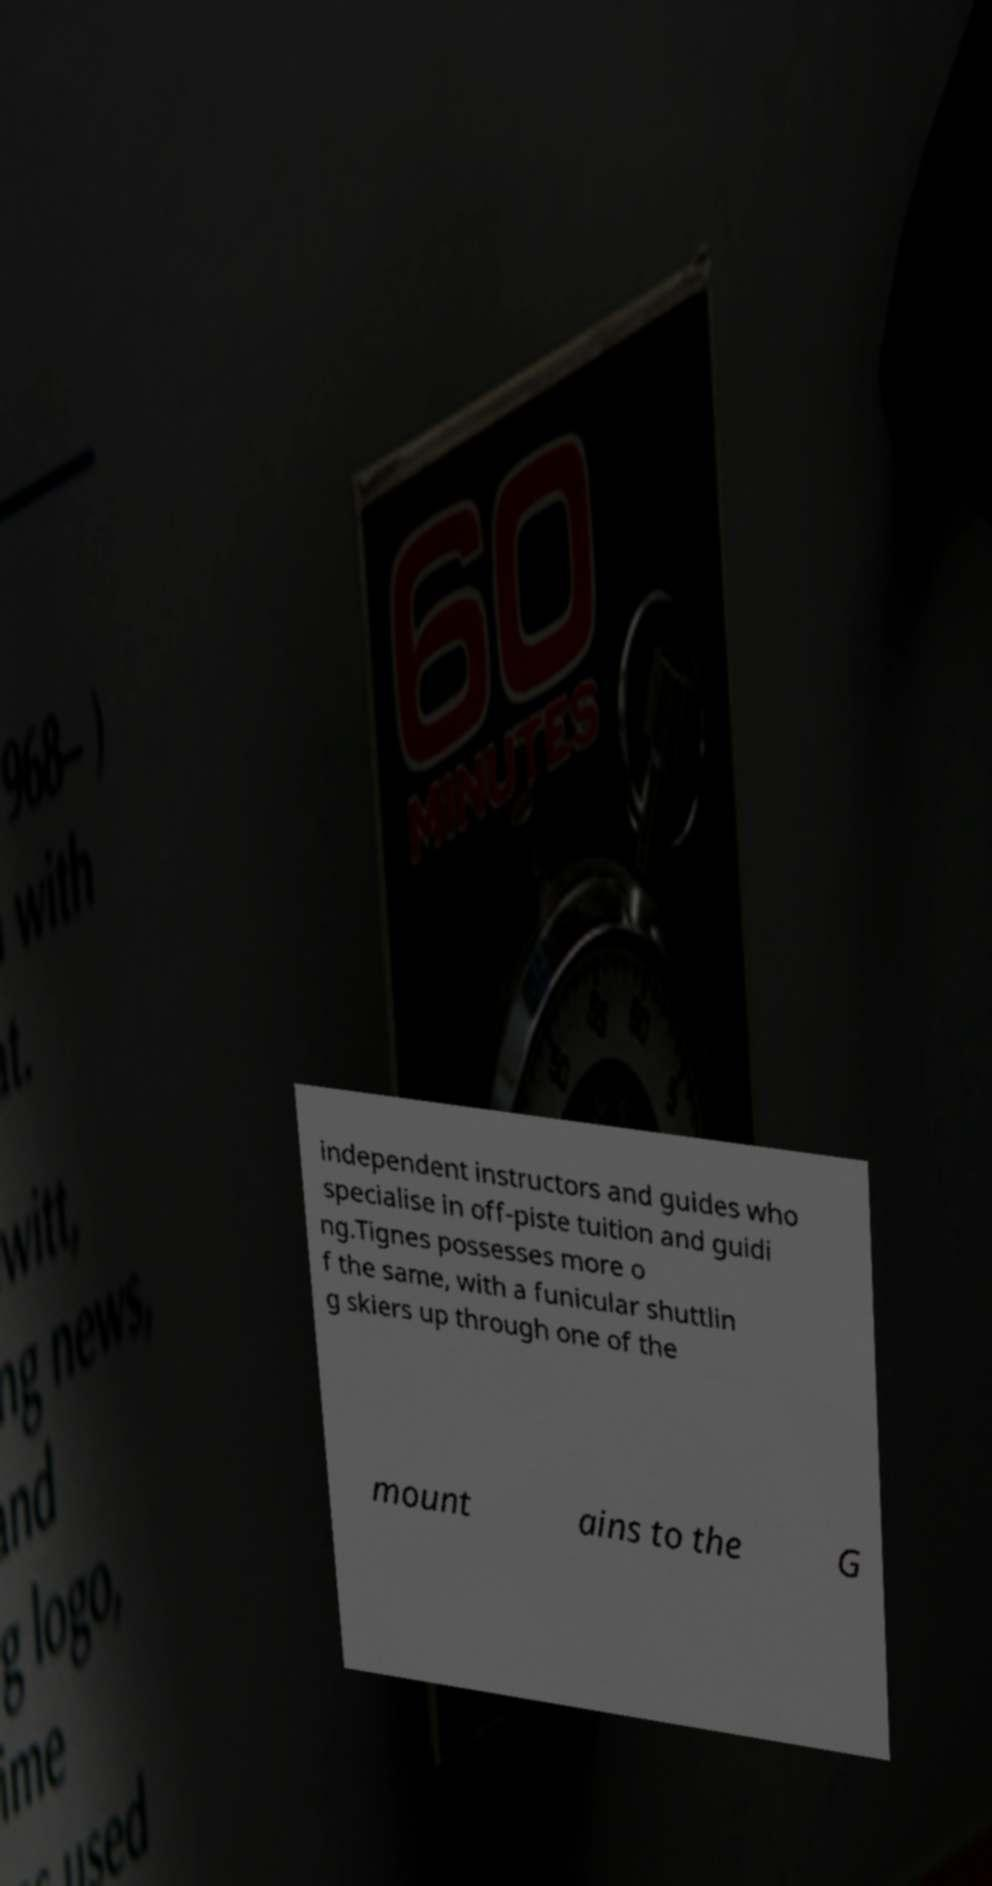For documentation purposes, I need the text within this image transcribed. Could you provide that? independent instructors and guides who specialise in off-piste tuition and guidi ng.Tignes possesses more o f the same, with a funicular shuttlin g skiers up through one of the mount ains to the G 